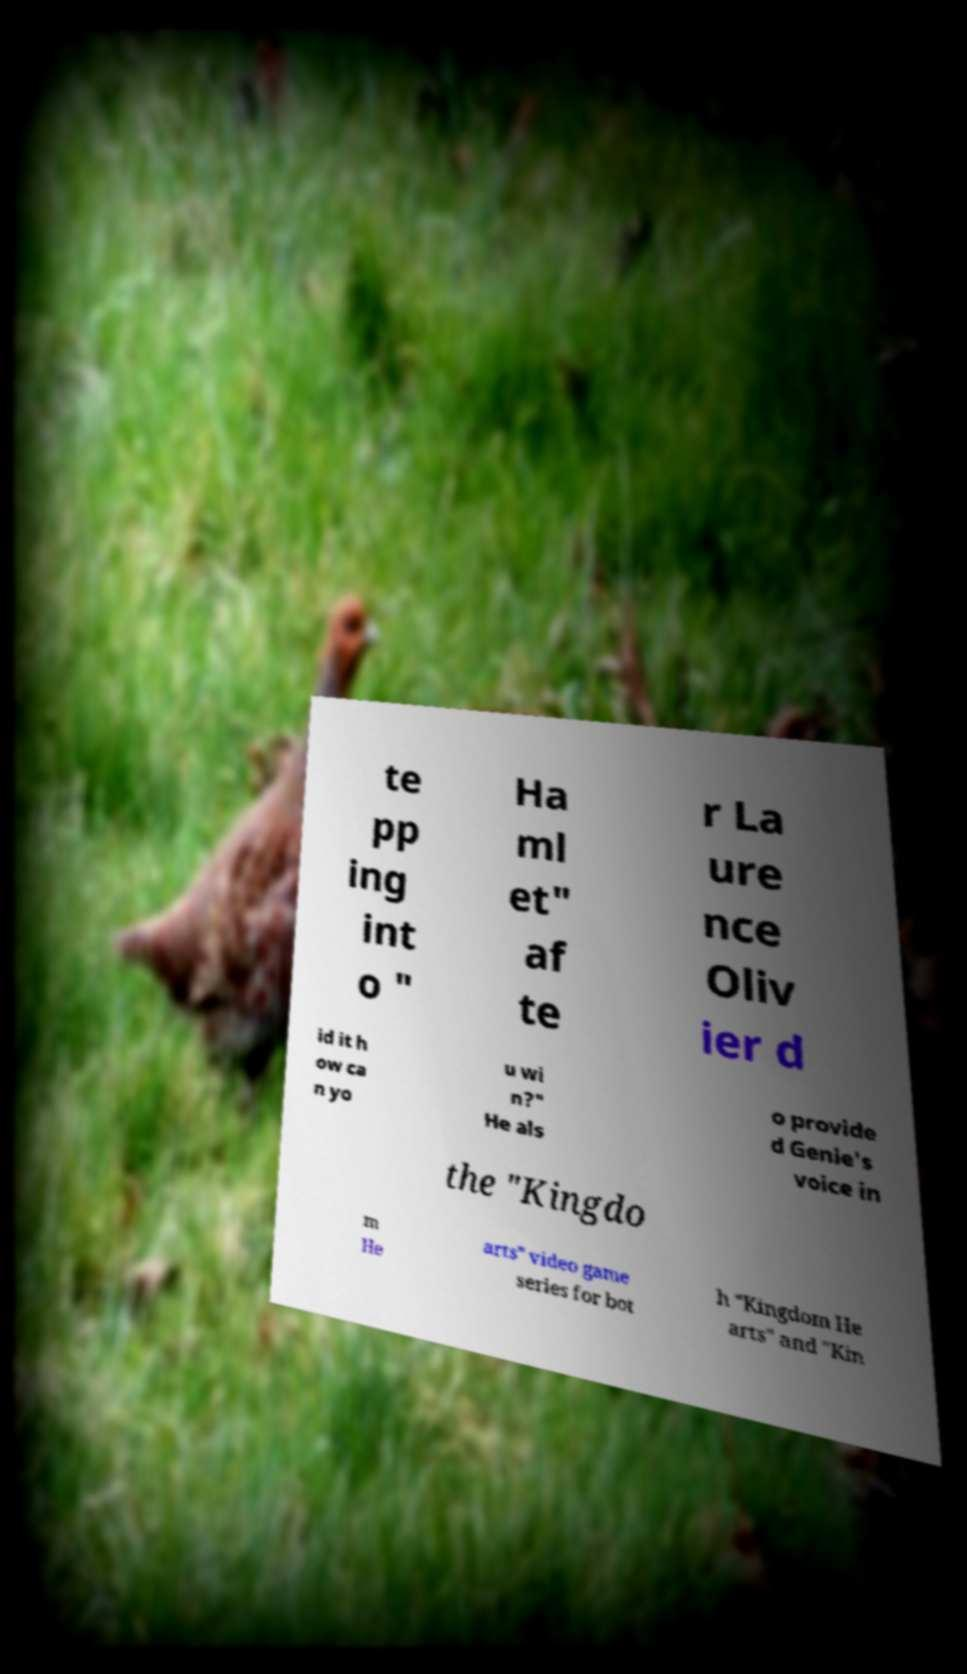Please read and relay the text visible in this image. What does it say? te pp ing int o " Ha ml et" af te r La ure nce Oliv ier d id it h ow ca n yo u wi n?" He als o provide d Genie's voice in the "Kingdo m He arts" video game series for bot h "Kingdom He arts" and "Kin 